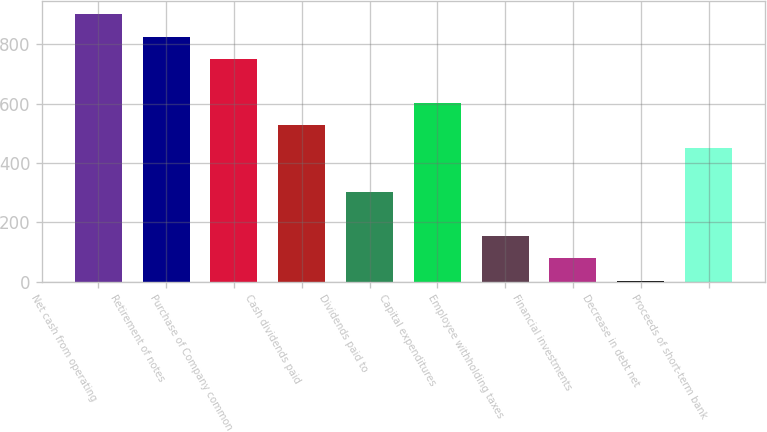Convert chart. <chart><loc_0><loc_0><loc_500><loc_500><bar_chart><fcel>Net cash from operating<fcel>Retirement of notes<fcel>Purchase of Company common<fcel>Cash dividends paid<fcel>Dividends paid to<fcel>Capital expenditures<fcel>Employee withholding taxes<fcel>Financial investments<fcel>Decrease in debt net<fcel>Proceeds of short-term bank<nl><fcel>900.6<fcel>825.8<fcel>751<fcel>526.6<fcel>302.2<fcel>601.4<fcel>152.6<fcel>77.8<fcel>3<fcel>451.8<nl></chart> 